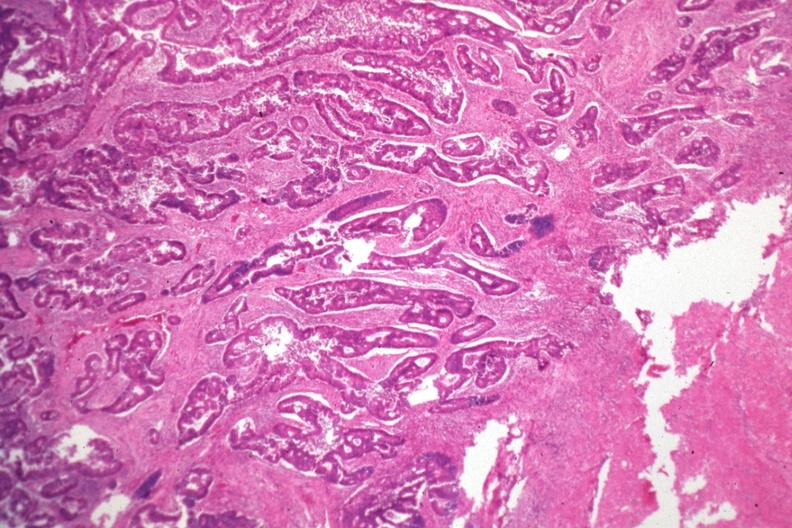where is this from?
Answer the question using a single word or phrase. Gastrointestinal system 